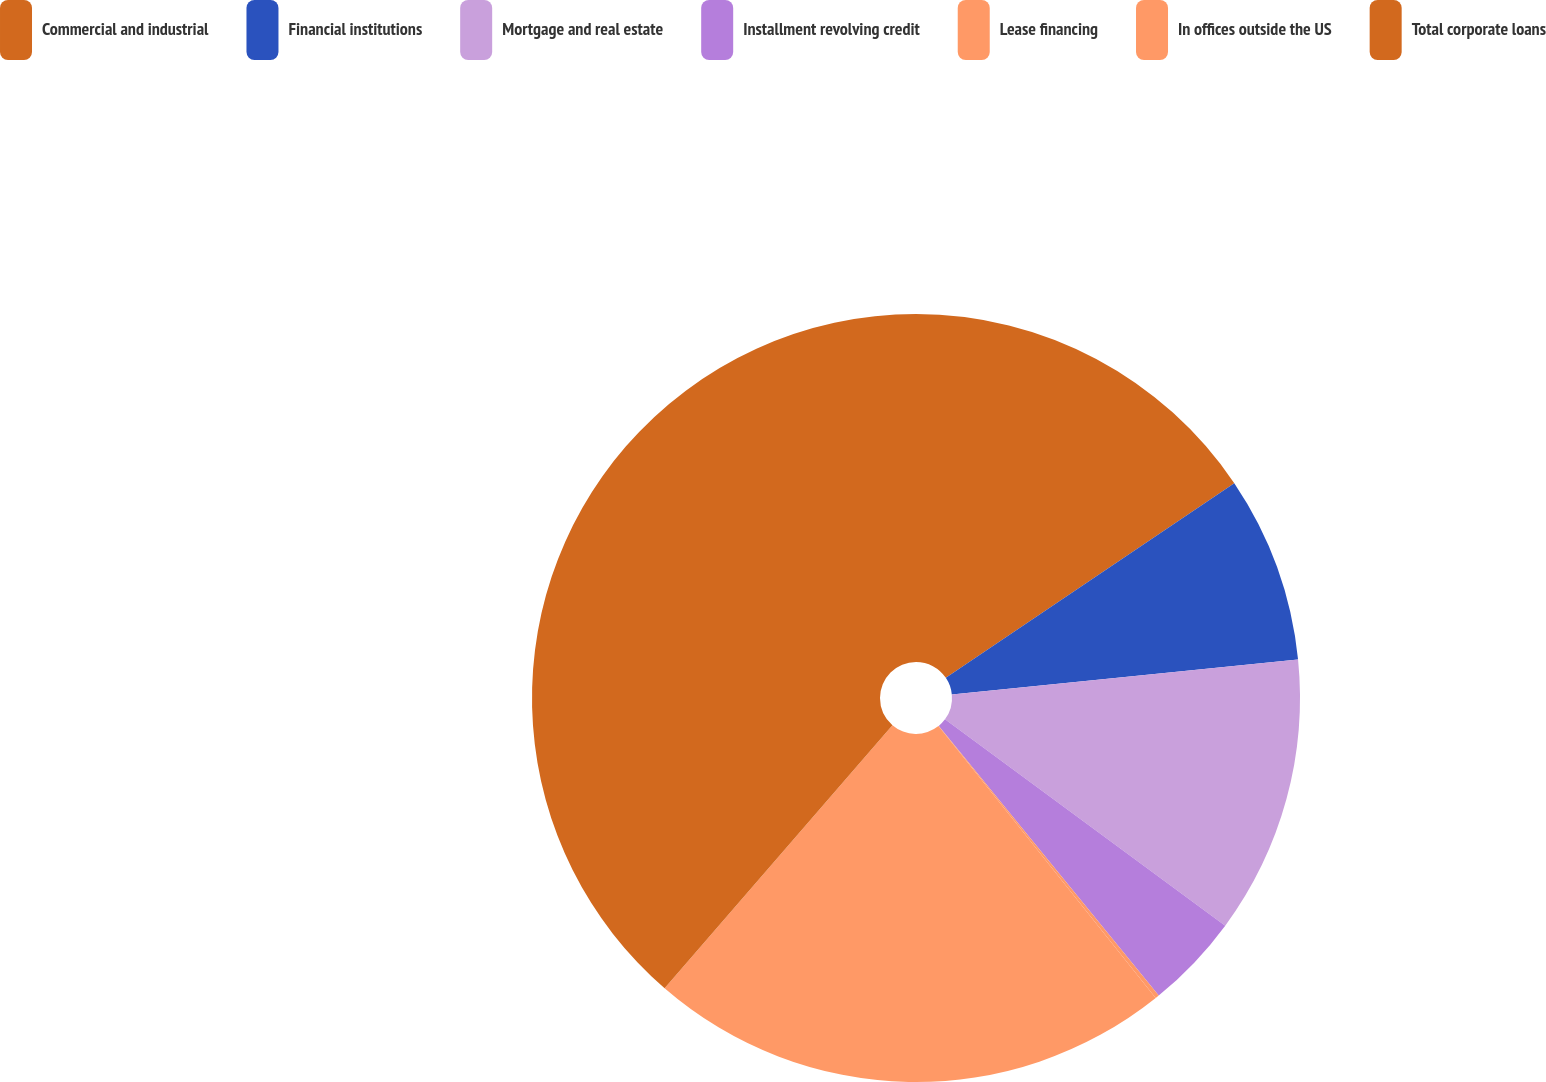Convert chart. <chart><loc_0><loc_0><loc_500><loc_500><pie_chart><fcel>Commercial and industrial<fcel>Financial institutions<fcel>Mortgage and real estate<fcel>Installment revolving credit<fcel>Lease financing<fcel>In offices outside the US<fcel>Total corporate loans<nl><fcel>15.55%<fcel>7.85%<fcel>11.7%<fcel>4.01%<fcel>0.16%<fcel>22.09%<fcel>38.64%<nl></chart> 